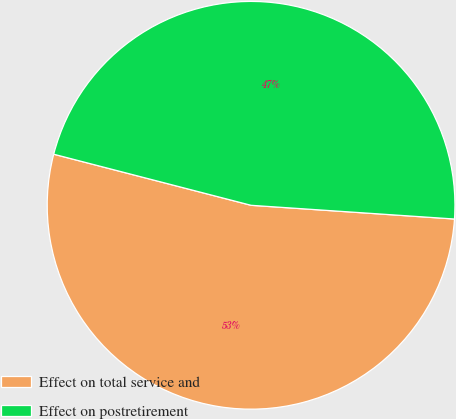Convert chart to OTSL. <chart><loc_0><loc_0><loc_500><loc_500><pie_chart><fcel>Effect on total service and<fcel>Effect on postretirement<nl><fcel>52.96%<fcel>47.04%<nl></chart> 